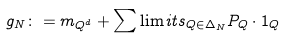Convert formula to latex. <formula><loc_0><loc_0><loc_500><loc_500>g _ { N } \colon = m _ { Q ^ { d } } + \sum \lim i t s _ { Q \in \Delta _ { N } } P _ { Q } \cdot 1 _ { Q }</formula> 